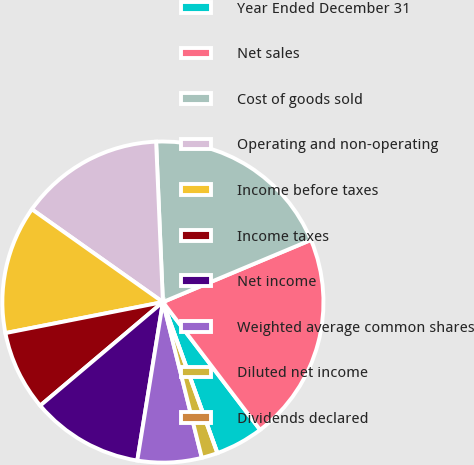Convert chart. <chart><loc_0><loc_0><loc_500><loc_500><pie_chart><fcel>Year Ended December 31<fcel>Net sales<fcel>Cost of goods sold<fcel>Operating and non-operating<fcel>Income before taxes<fcel>Income taxes<fcel>Net income<fcel>Weighted average common shares<fcel>Diluted net income<fcel>Dividends declared<nl><fcel>4.84%<fcel>20.97%<fcel>19.35%<fcel>14.52%<fcel>12.9%<fcel>8.06%<fcel>11.29%<fcel>6.45%<fcel>1.61%<fcel>0.0%<nl></chart> 